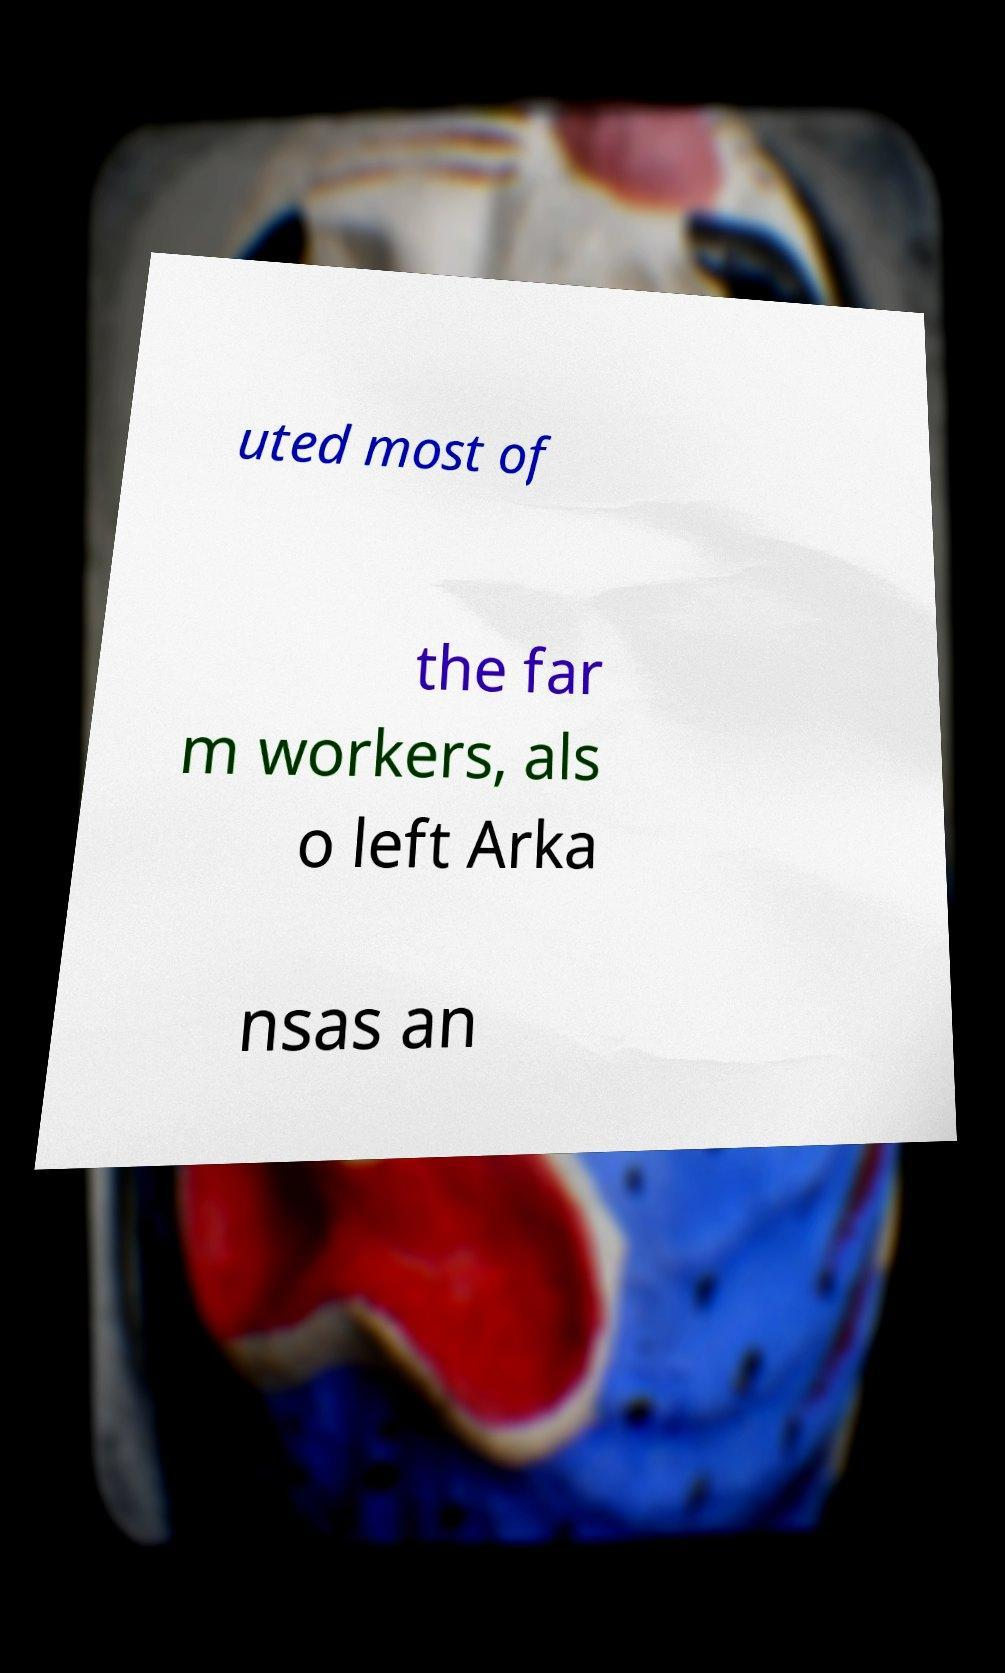Please read and relay the text visible in this image. What does it say? uted most of the far m workers, als o left Arka nsas an 